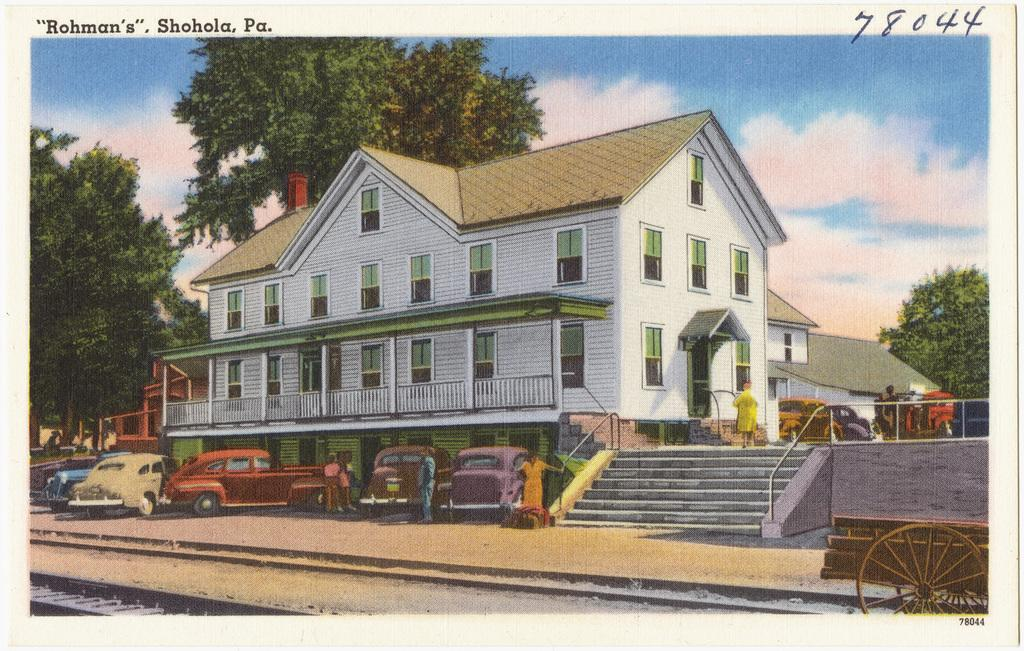What is the main subject of the image? The image contains a painting. What elements are depicted in the painting? The painting depicts cars, buildings, trees, stairs, and persons. What is the condition of the sky in the painting? The sky in the painting is cloudy. What additional information is present at the top of the image? There are texts and numbers written at the top of the image. Can you tell me how many cacti are present in the painting? There are no cacti depicted in the painting; it features cars, buildings, trees, stairs, and persons. What type of rod is used by the persons in the painting? There is no rod present in the painting; the persons are not depicted using any tools or objects. 